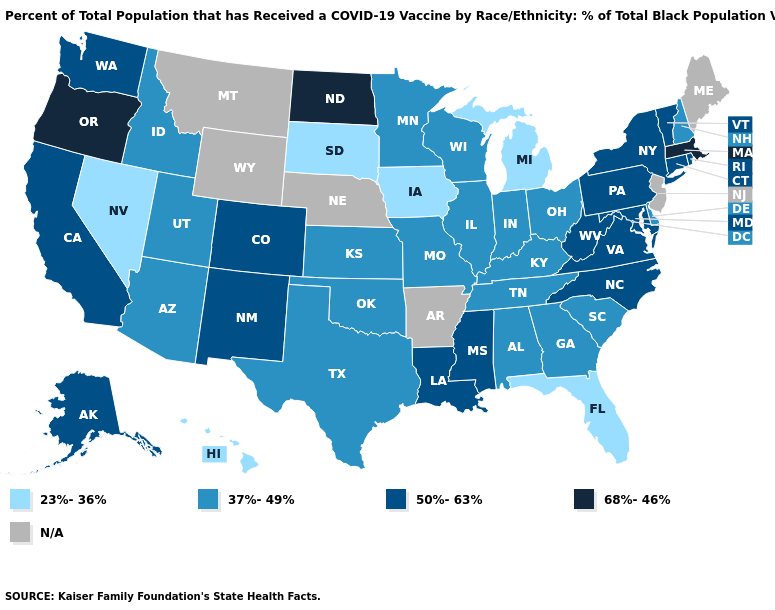Which states have the highest value in the USA?
Write a very short answer. Massachusetts, North Dakota, Oregon. Name the states that have a value in the range N/A?
Quick response, please. Arkansas, Maine, Montana, Nebraska, New Jersey, Wyoming. Does the first symbol in the legend represent the smallest category?
Short answer required. Yes. Name the states that have a value in the range 68%-46%?
Be succinct. Massachusetts, North Dakota, Oregon. Among the states that border New Hampshire , which have the lowest value?
Be succinct. Vermont. Name the states that have a value in the range N/A?
Short answer required. Arkansas, Maine, Montana, Nebraska, New Jersey, Wyoming. Which states have the lowest value in the Northeast?
Write a very short answer. New Hampshire. What is the highest value in the USA?
Give a very brief answer. 68%-46%. What is the value of Connecticut?
Answer briefly. 50%-63%. Which states have the lowest value in the USA?
Answer briefly. Florida, Hawaii, Iowa, Michigan, Nevada, South Dakota. Is the legend a continuous bar?
Keep it brief. No. Which states have the lowest value in the West?
Concise answer only. Hawaii, Nevada. Name the states that have a value in the range 50%-63%?
Short answer required. Alaska, California, Colorado, Connecticut, Louisiana, Maryland, Mississippi, New Mexico, New York, North Carolina, Pennsylvania, Rhode Island, Vermont, Virginia, Washington, West Virginia. What is the value of Oklahoma?
Give a very brief answer. 37%-49%. 